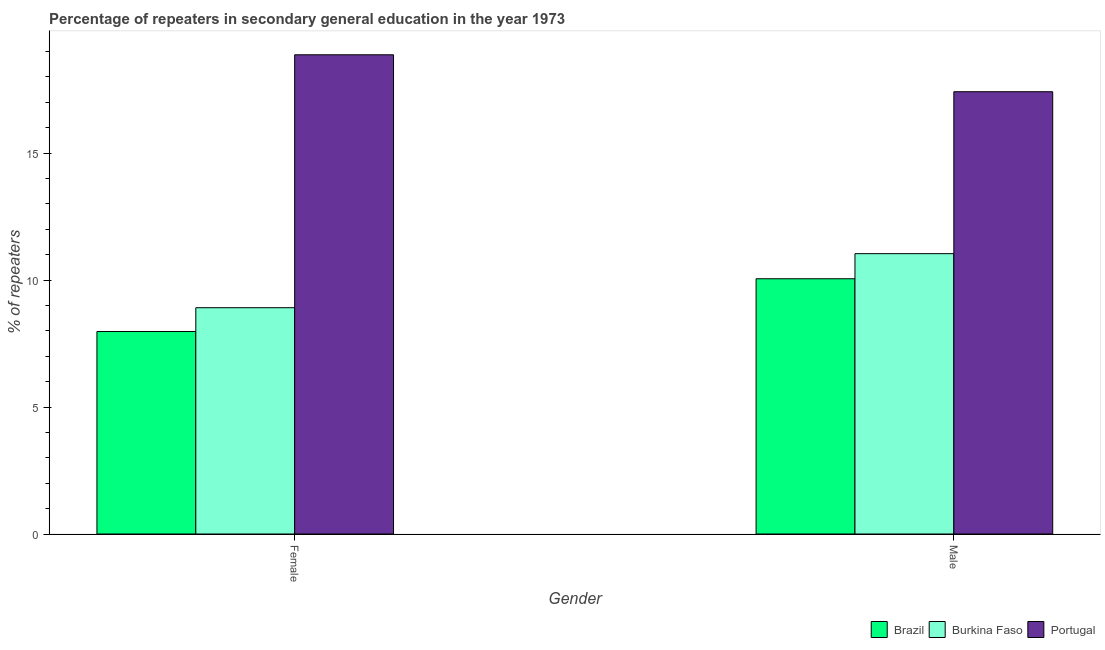How many different coloured bars are there?
Your response must be concise. 3. How many groups of bars are there?
Your response must be concise. 2. Are the number of bars per tick equal to the number of legend labels?
Ensure brevity in your answer.  Yes. How many bars are there on the 2nd tick from the left?
Your answer should be very brief. 3. How many bars are there on the 1st tick from the right?
Offer a terse response. 3. What is the label of the 2nd group of bars from the left?
Your answer should be compact. Male. What is the percentage of female repeaters in Burkina Faso?
Provide a short and direct response. 8.91. Across all countries, what is the maximum percentage of female repeaters?
Your answer should be very brief. 18.87. Across all countries, what is the minimum percentage of female repeaters?
Offer a terse response. 7.97. In which country was the percentage of female repeaters maximum?
Your answer should be very brief. Portugal. What is the total percentage of male repeaters in the graph?
Provide a short and direct response. 38.5. What is the difference between the percentage of male repeaters in Burkina Faso and that in Portugal?
Offer a terse response. -6.38. What is the difference between the percentage of male repeaters in Portugal and the percentage of female repeaters in Burkina Faso?
Your answer should be compact. 8.51. What is the average percentage of female repeaters per country?
Your response must be concise. 11.92. What is the difference between the percentage of female repeaters and percentage of male repeaters in Portugal?
Keep it short and to the point. 1.45. What is the ratio of the percentage of female repeaters in Burkina Faso to that in Portugal?
Provide a succinct answer. 0.47. In how many countries, is the percentage of male repeaters greater than the average percentage of male repeaters taken over all countries?
Give a very brief answer. 1. What does the 3rd bar from the left in Male represents?
Make the answer very short. Portugal. What does the 1st bar from the right in Male represents?
Give a very brief answer. Portugal. Are all the bars in the graph horizontal?
Provide a short and direct response. No. Does the graph contain grids?
Give a very brief answer. No. Where does the legend appear in the graph?
Your answer should be very brief. Bottom right. How many legend labels are there?
Provide a succinct answer. 3. What is the title of the graph?
Provide a succinct answer. Percentage of repeaters in secondary general education in the year 1973. Does "Sierra Leone" appear as one of the legend labels in the graph?
Your answer should be compact. No. What is the label or title of the Y-axis?
Your answer should be compact. % of repeaters. What is the % of repeaters of Brazil in Female?
Your answer should be compact. 7.97. What is the % of repeaters in Burkina Faso in Female?
Keep it short and to the point. 8.91. What is the % of repeaters of Portugal in Female?
Provide a succinct answer. 18.87. What is the % of repeaters of Brazil in Male?
Provide a short and direct response. 10.05. What is the % of repeaters in Burkina Faso in Male?
Provide a succinct answer. 11.04. What is the % of repeaters in Portugal in Male?
Offer a very short reply. 17.42. Across all Gender, what is the maximum % of repeaters in Brazil?
Offer a terse response. 10.05. Across all Gender, what is the maximum % of repeaters in Burkina Faso?
Your answer should be very brief. 11.04. Across all Gender, what is the maximum % of repeaters of Portugal?
Make the answer very short. 18.87. Across all Gender, what is the minimum % of repeaters in Brazil?
Offer a very short reply. 7.97. Across all Gender, what is the minimum % of repeaters of Burkina Faso?
Provide a succinct answer. 8.91. Across all Gender, what is the minimum % of repeaters of Portugal?
Keep it short and to the point. 17.42. What is the total % of repeaters in Brazil in the graph?
Provide a short and direct response. 18.02. What is the total % of repeaters in Burkina Faso in the graph?
Ensure brevity in your answer.  19.95. What is the total % of repeaters of Portugal in the graph?
Your response must be concise. 36.29. What is the difference between the % of repeaters of Brazil in Female and that in Male?
Make the answer very short. -2.08. What is the difference between the % of repeaters in Burkina Faso in Female and that in Male?
Offer a terse response. -2.13. What is the difference between the % of repeaters in Portugal in Female and that in Male?
Provide a short and direct response. 1.45. What is the difference between the % of repeaters of Brazil in Female and the % of repeaters of Burkina Faso in Male?
Make the answer very short. -3.07. What is the difference between the % of repeaters of Brazil in Female and the % of repeaters of Portugal in Male?
Offer a terse response. -9.44. What is the difference between the % of repeaters of Burkina Faso in Female and the % of repeaters of Portugal in Male?
Provide a succinct answer. -8.51. What is the average % of repeaters of Brazil per Gender?
Provide a succinct answer. 9.01. What is the average % of repeaters in Burkina Faso per Gender?
Make the answer very short. 9.97. What is the average % of repeaters of Portugal per Gender?
Your answer should be very brief. 18.14. What is the difference between the % of repeaters of Brazil and % of repeaters of Burkina Faso in Female?
Give a very brief answer. -0.94. What is the difference between the % of repeaters of Brazil and % of repeaters of Portugal in Female?
Provide a succinct answer. -10.9. What is the difference between the % of repeaters of Burkina Faso and % of repeaters of Portugal in Female?
Give a very brief answer. -9.96. What is the difference between the % of repeaters of Brazil and % of repeaters of Burkina Faso in Male?
Offer a very short reply. -0.99. What is the difference between the % of repeaters in Brazil and % of repeaters in Portugal in Male?
Your answer should be compact. -7.36. What is the difference between the % of repeaters in Burkina Faso and % of repeaters in Portugal in Male?
Offer a terse response. -6.38. What is the ratio of the % of repeaters in Brazil in Female to that in Male?
Your answer should be compact. 0.79. What is the ratio of the % of repeaters in Burkina Faso in Female to that in Male?
Keep it short and to the point. 0.81. What is the ratio of the % of repeaters in Portugal in Female to that in Male?
Offer a very short reply. 1.08. What is the difference between the highest and the second highest % of repeaters in Brazil?
Offer a very short reply. 2.08. What is the difference between the highest and the second highest % of repeaters of Burkina Faso?
Offer a very short reply. 2.13. What is the difference between the highest and the second highest % of repeaters in Portugal?
Your response must be concise. 1.45. What is the difference between the highest and the lowest % of repeaters in Brazil?
Give a very brief answer. 2.08. What is the difference between the highest and the lowest % of repeaters in Burkina Faso?
Provide a succinct answer. 2.13. What is the difference between the highest and the lowest % of repeaters in Portugal?
Provide a short and direct response. 1.45. 